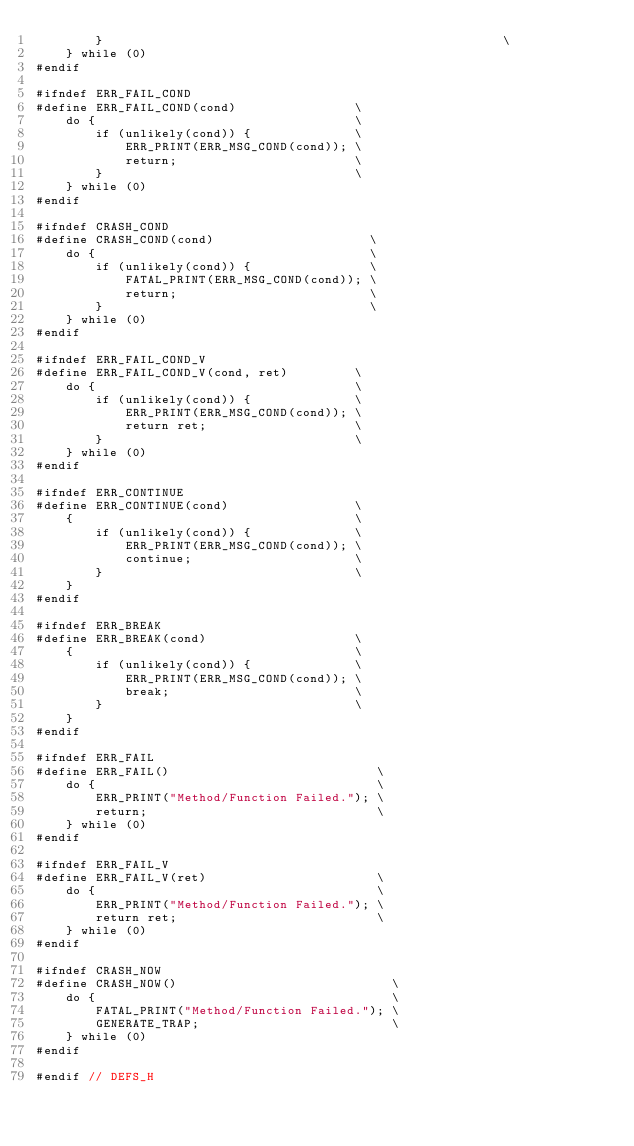<code> <loc_0><loc_0><loc_500><loc_500><_C++_>		}                                                      \
	} while (0)
#endif

#ifndef ERR_FAIL_COND
#define ERR_FAIL_COND(cond)                \
	do {                                   \
		if (unlikely(cond)) {              \
			ERR_PRINT(ERR_MSG_COND(cond)); \
			return;                        \
		}                                  \
	} while (0)
#endif

#ifndef CRASH_COND
#define CRASH_COND(cond)                     \
	do {                                     \
		if (unlikely(cond)) {                \
			FATAL_PRINT(ERR_MSG_COND(cond)); \
			return;                          \
		}                                    \
	} while (0)
#endif

#ifndef ERR_FAIL_COND_V
#define ERR_FAIL_COND_V(cond, ret)         \
	do {                                   \
		if (unlikely(cond)) {              \
			ERR_PRINT(ERR_MSG_COND(cond)); \
			return ret;                    \
		}                                  \
	} while (0)
#endif

#ifndef ERR_CONTINUE
#define ERR_CONTINUE(cond)                 \
	{                                      \
		if (unlikely(cond)) {              \
			ERR_PRINT(ERR_MSG_COND(cond)); \
			continue;                      \
		}                                  \
	}
#endif

#ifndef ERR_BREAK
#define ERR_BREAK(cond)                    \
	{                                      \
		if (unlikely(cond)) {              \
			ERR_PRINT(ERR_MSG_COND(cond)); \
			break;                         \
		}                                  \
	}
#endif

#ifndef ERR_FAIL
#define ERR_FAIL()                            \
	do {                                      \
		ERR_PRINT("Method/Function Failed."); \
		return;                               \
	} while (0)
#endif

#ifndef ERR_FAIL_V
#define ERR_FAIL_V(ret)                       \
	do {                                      \
		ERR_PRINT("Method/Function Failed."); \
		return ret;                           \
	} while (0)
#endif

#ifndef CRASH_NOW
#define CRASH_NOW()                             \
	do {                                        \
		FATAL_PRINT("Method/Function Failed."); \
		GENERATE_TRAP;                          \
	} while (0)
#endif

#endif // DEFS_H
</code> 